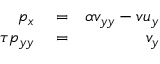<formula> <loc_0><loc_0><loc_500><loc_500>\begin{array} { r l r } { p _ { x } } & = } & { \alpha v _ { y y } - v u _ { y } } \\ { \tau p _ { y y } } & = } & { v _ { y } } \end{array}</formula> 